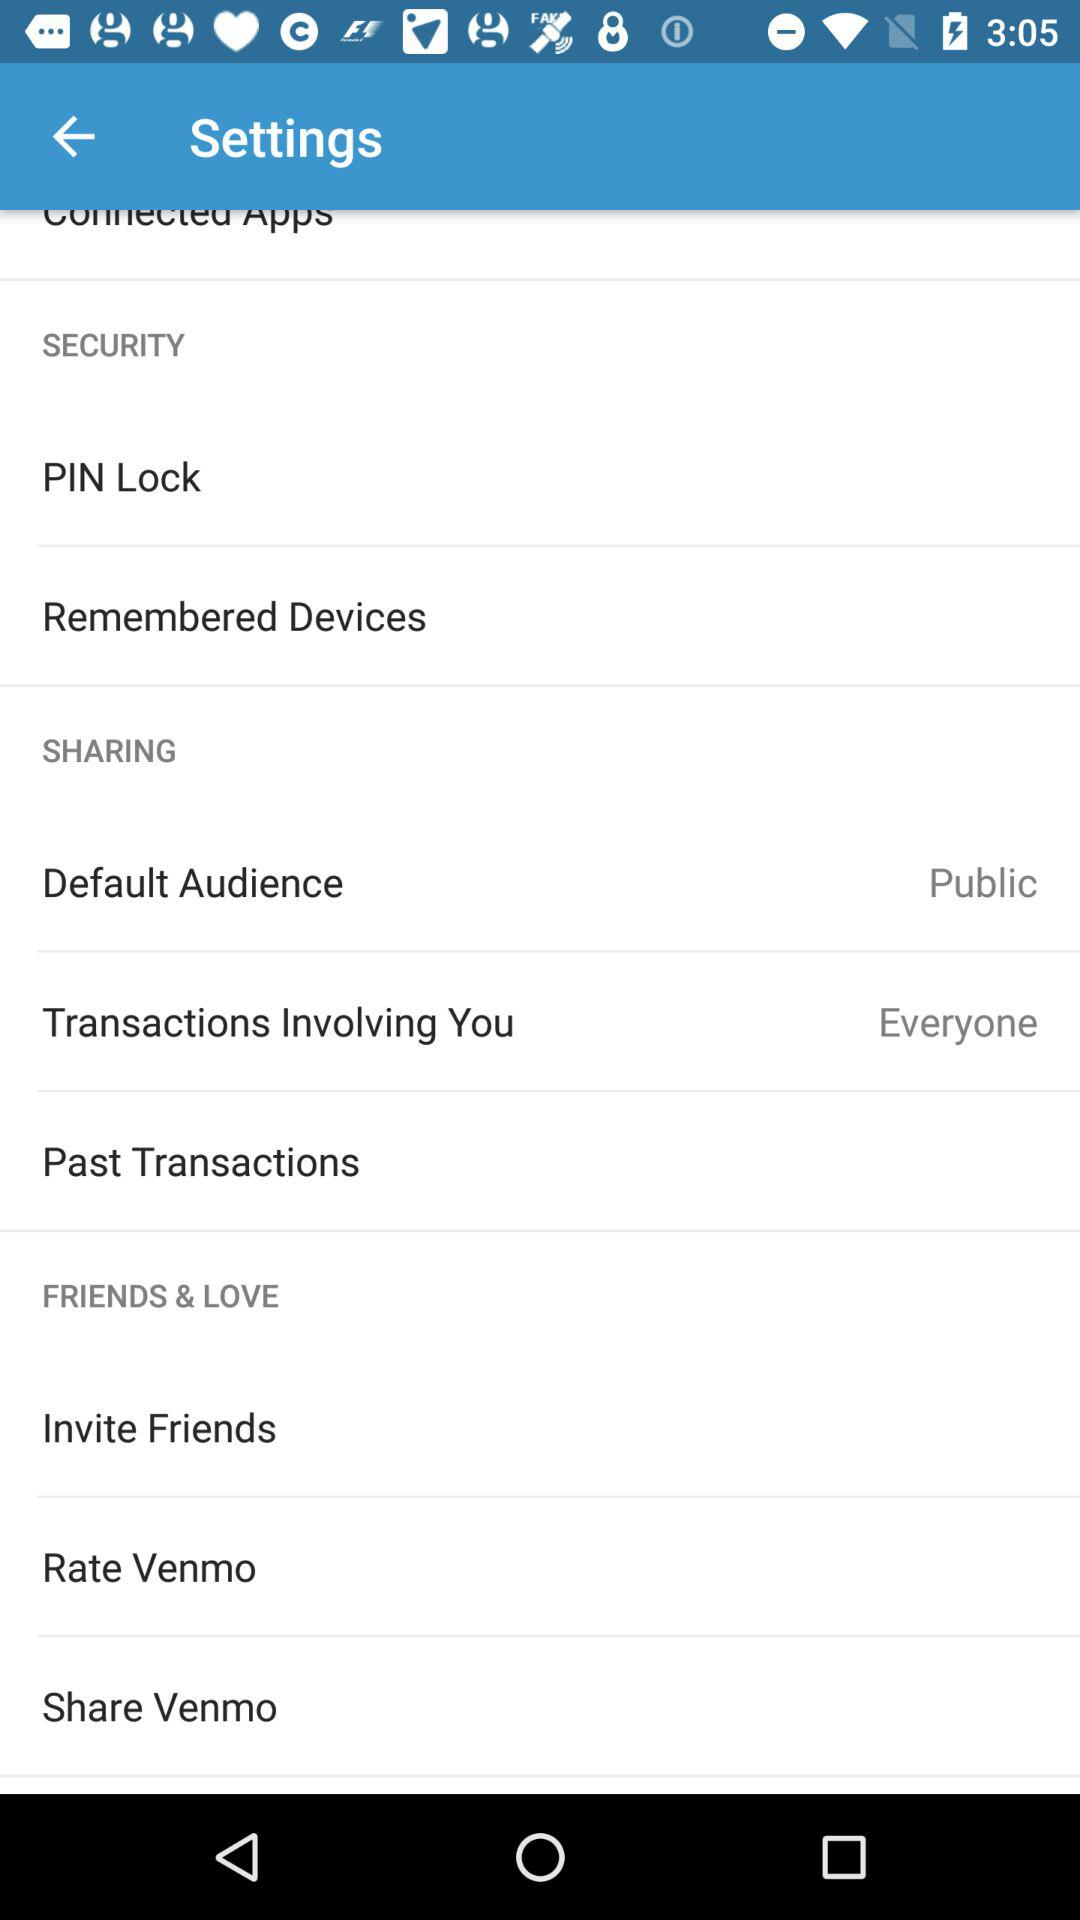Which option is chosen for sharing?
When the provided information is insufficient, respond with <no answer>. <no answer> 